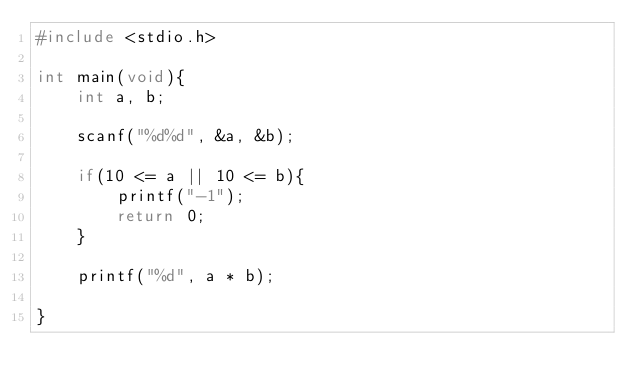<code> <loc_0><loc_0><loc_500><loc_500><_C_>#include <stdio.h>

int main(void){
    int a, b;

    scanf("%d%d", &a, &b);

    if(10 <= a || 10 <= b){
        printf("-1");
        return 0;
    }

    printf("%d", a * b);
    
}</code> 